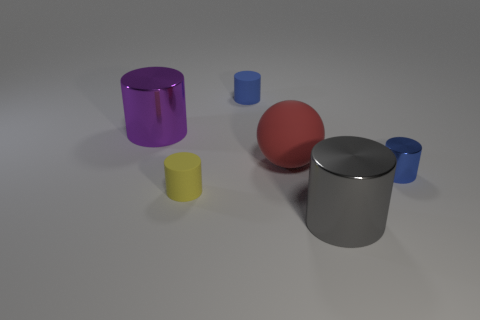There is a shiny cylinder that is left of the metallic cylinder that is in front of the small yellow rubber cylinder; how big is it?
Your answer should be compact. Large. Do the tiny metallic cylinder and the rubber cylinder behind the big red matte ball have the same color?
Keep it short and to the point. Yes. There is a red object that is the same size as the purple thing; what material is it?
Offer a terse response. Rubber. Are there fewer tiny rubber objects that are in front of the large gray shiny cylinder than red matte spheres that are in front of the yellow rubber cylinder?
Offer a very short reply. No. The big metal object that is in front of the matte thing that is in front of the small blue shiny thing is what shape?
Offer a terse response. Cylinder. Are any tiny cylinders visible?
Your response must be concise. Yes. What is the color of the large object that is left of the small blue rubber cylinder?
Offer a terse response. Purple. There is a large purple object; are there any large purple cylinders in front of it?
Your answer should be compact. No. Is the number of red objects greater than the number of large yellow shiny blocks?
Offer a terse response. Yes. There is a thing to the right of the big cylinder that is right of the tiny rubber object that is to the right of the yellow cylinder; what is its color?
Keep it short and to the point. Blue. 